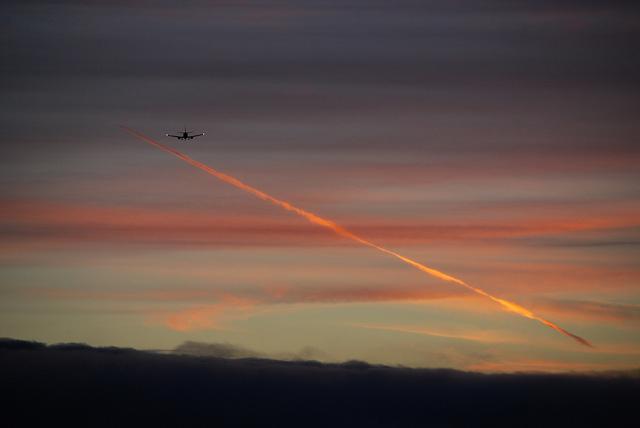Is there an airplane in the sky?
Give a very brief answer. Yes. Is this the Golden Gate bridge?
Write a very short answer. No. IS the sun out?
Answer briefly. No. What is flying?
Answer briefly. Airplane. What is in the sky?
Concise answer only. Plane. What color is the sky?
Short answer required. Orange. Is that a boat?
Be succinct. No. What is the cause of the line across the sky?
Write a very short answer. Airplane. Is it day or night in the photo?
Quick response, please. Night. 